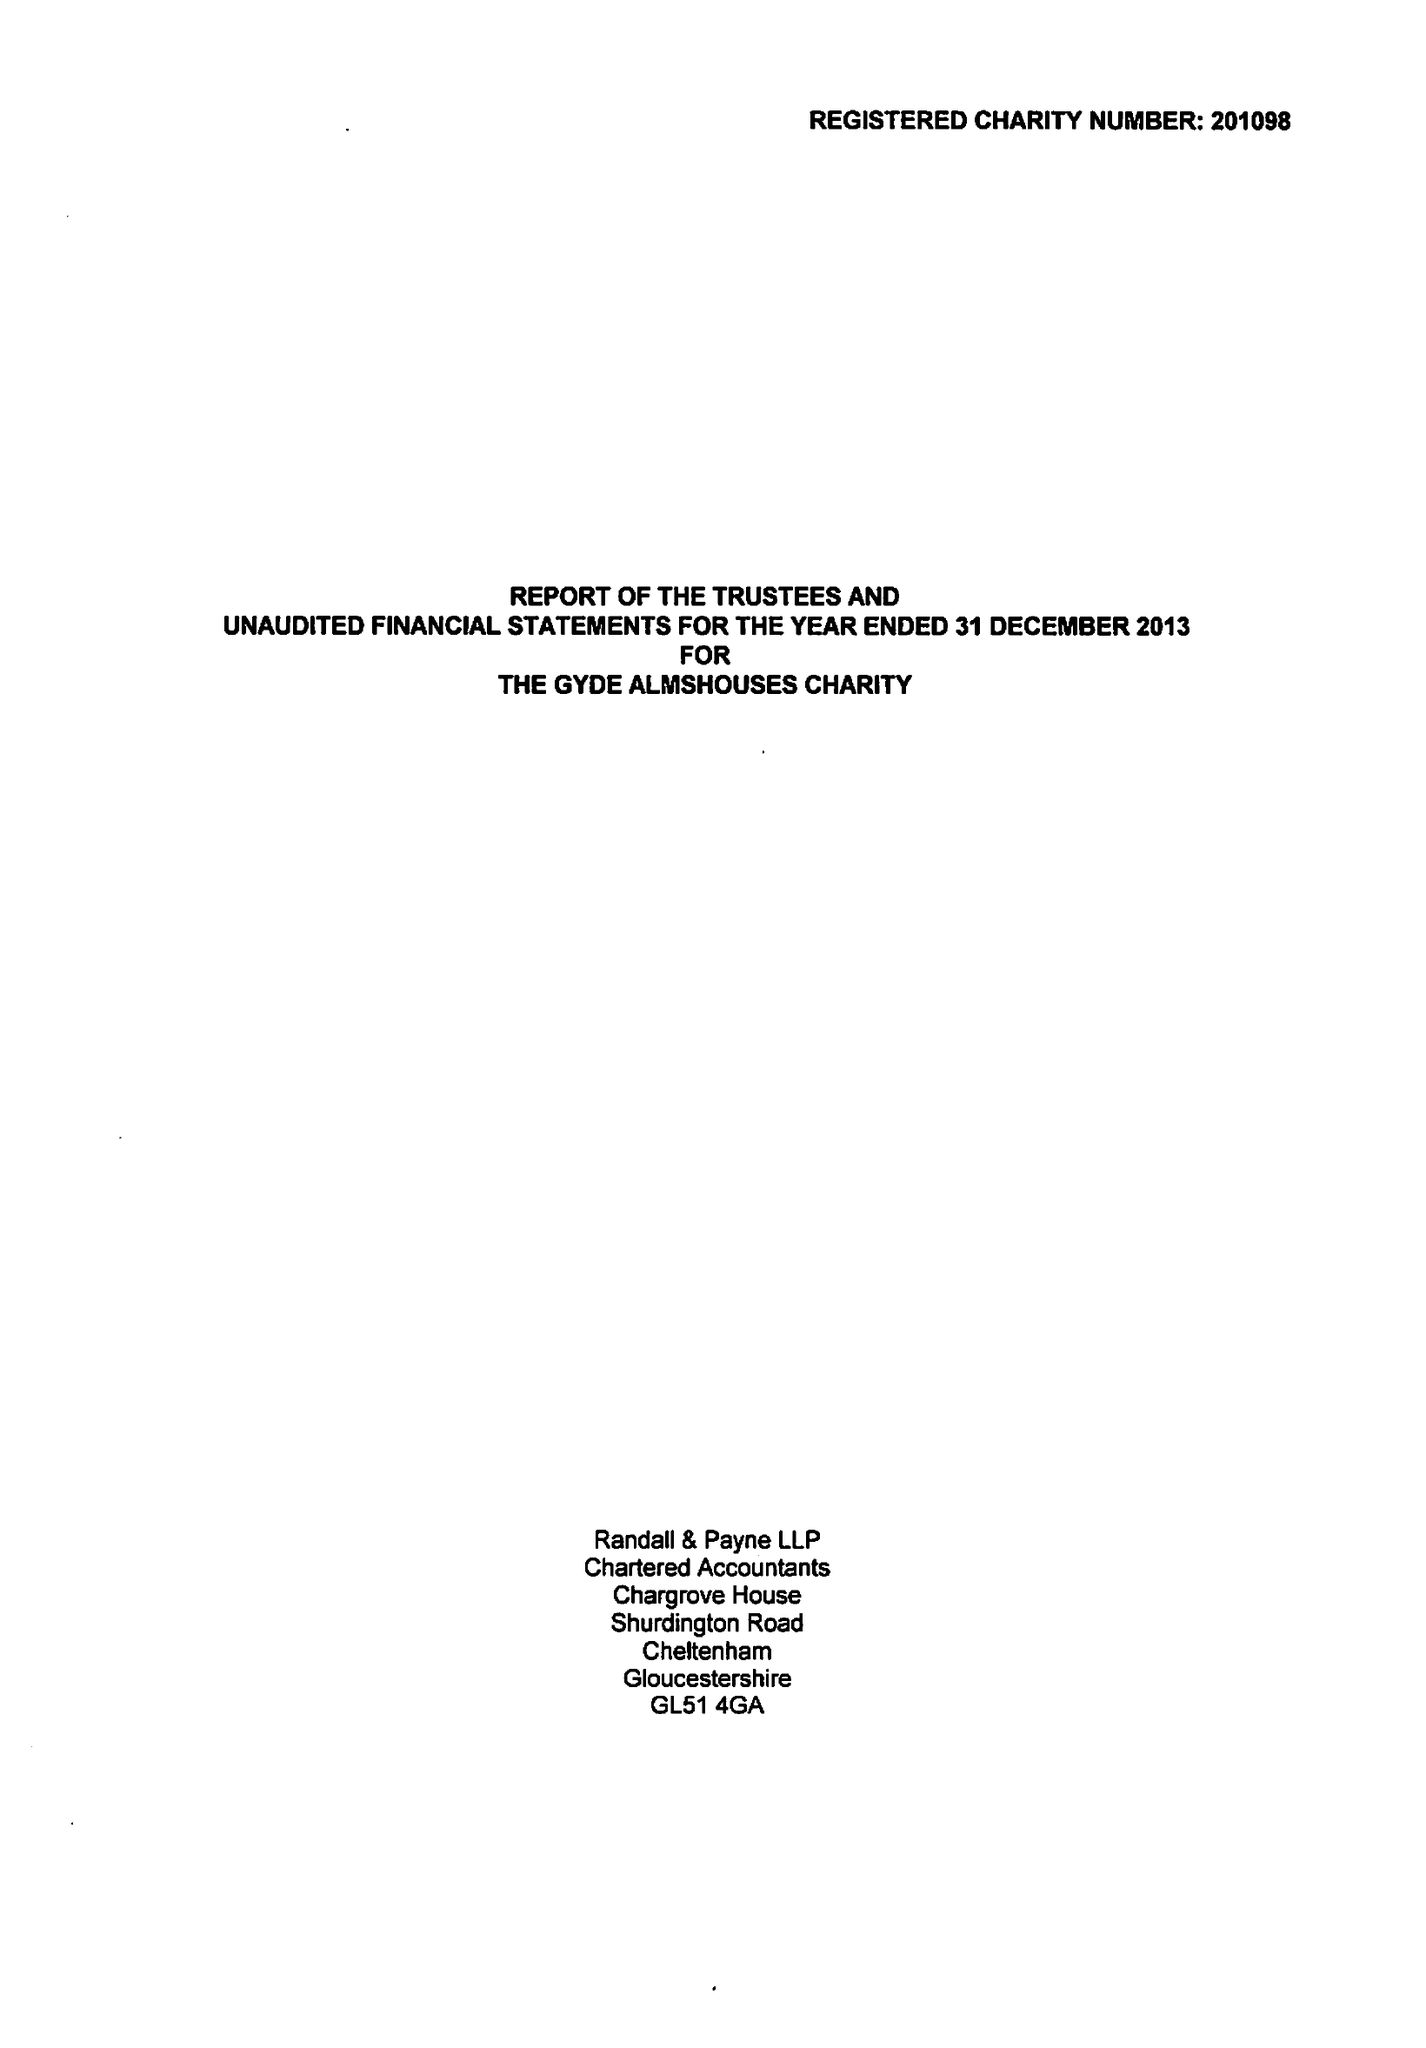What is the value for the report_date?
Answer the question using a single word or phrase. 2013-12-31 